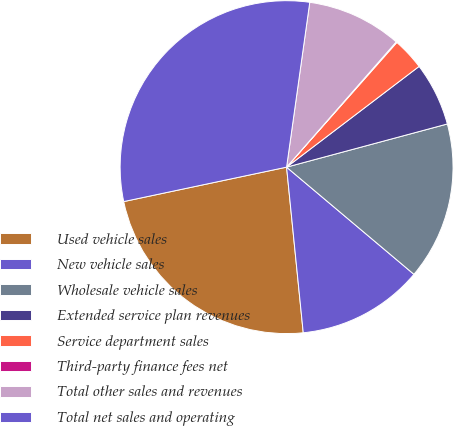Convert chart to OTSL. <chart><loc_0><loc_0><loc_500><loc_500><pie_chart><fcel>Used vehicle sales<fcel>New vehicle sales<fcel>Wholesale vehicle sales<fcel>Extended service plan revenues<fcel>Service department sales<fcel>Third-party finance fees net<fcel>Total other sales and revenues<fcel>Total net sales and operating<nl><fcel>23.28%<fcel>12.27%<fcel>15.31%<fcel>6.17%<fcel>3.13%<fcel>0.08%<fcel>9.22%<fcel>30.54%<nl></chart> 